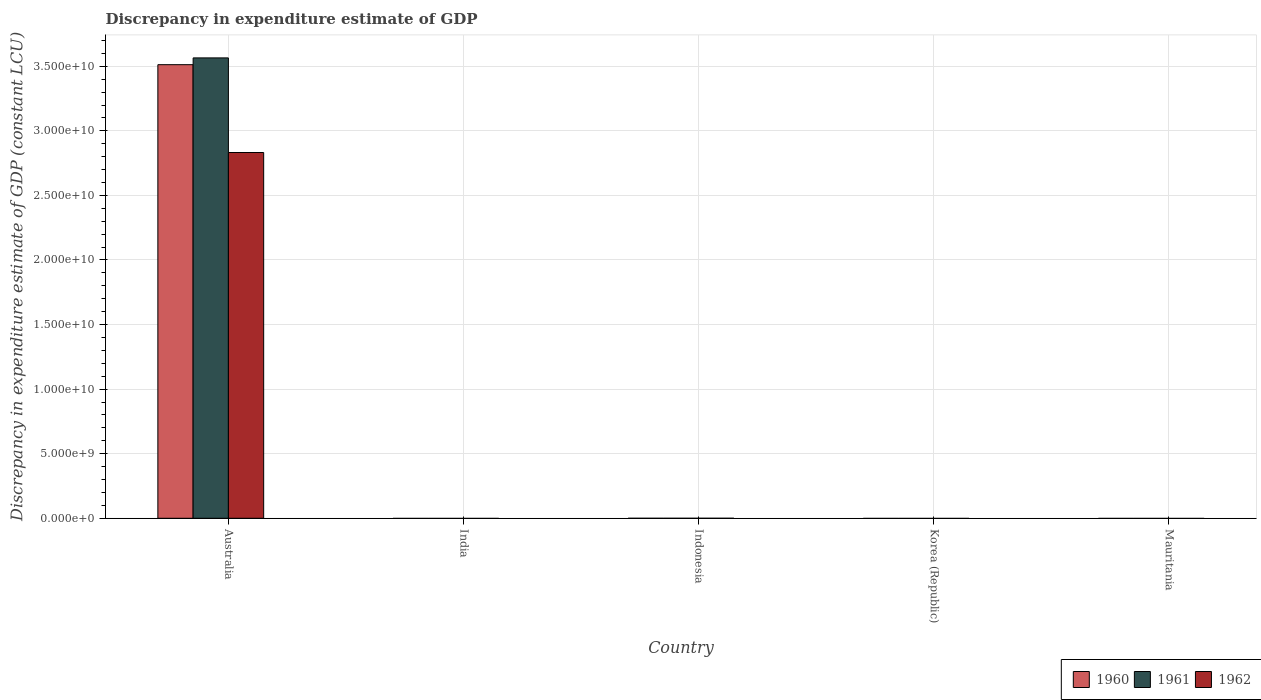How many different coloured bars are there?
Provide a succinct answer. 3. Are the number of bars per tick equal to the number of legend labels?
Provide a succinct answer. No. What is the label of the 3rd group of bars from the left?
Your response must be concise. Indonesia. What is the discrepancy in expenditure estimate of GDP in 1961 in Australia?
Offer a terse response. 3.56e+1. Across all countries, what is the maximum discrepancy in expenditure estimate of GDP in 1960?
Make the answer very short. 3.51e+1. Across all countries, what is the minimum discrepancy in expenditure estimate of GDP in 1961?
Offer a very short reply. 0. In which country was the discrepancy in expenditure estimate of GDP in 1961 maximum?
Provide a short and direct response. Australia. What is the total discrepancy in expenditure estimate of GDP in 1962 in the graph?
Offer a terse response. 2.83e+1. What is the difference between the discrepancy in expenditure estimate of GDP in 1962 in Mauritania and the discrepancy in expenditure estimate of GDP in 1961 in India?
Offer a terse response. 0. What is the average discrepancy in expenditure estimate of GDP in 1960 per country?
Your answer should be very brief. 7.02e+09. What is the difference between the discrepancy in expenditure estimate of GDP of/in 1960 and discrepancy in expenditure estimate of GDP of/in 1961 in Australia?
Provide a short and direct response. -5.25e+08. What is the difference between the highest and the lowest discrepancy in expenditure estimate of GDP in 1962?
Offer a very short reply. 2.83e+1. In how many countries, is the discrepancy in expenditure estimate of GDP in 1960 greater than the average discrepancy in expenditure estimate of GDP in 1960 taken over all countries?
Make the answer very short. 1. Is it the case that in every country, the sum of the discrepancy in expenditure estimate of GDP in 1961 and discrepancy in expenditure estimate of GDP in 1962 is greater than the discrepancy in expenditure estimate of GDP in 1960?
Keep it short and to the point. No. What is the difference between two consecutive major ticks on the Y-axis?
Offer a terse response. 5.00e+09. Are the values on the major ticks of Y-axis written in scientific E-notation?
Your answer should be very brief. Yes. Does the graph contain any zero values?
Make the answer very short. Yes. What is the title of the graph?
Make the answer very short. Discrepancy in expenditure estimate of GDP. What is the label or title of the Y-axis?
Your answer should be compact. Discrepancy in expenditure estimate of GDP (constant LCU). What is the Discrepancy in expenditure estimate of GDP (constant LCU) of 1960 in Australia?
Your response must be concise. 3.51e+1. What is the Discrepancy in expenditure estimate of GDP (constant LCU) in 1961 in Australia?
Provide a succinct answer. 3.56e+1. What is the Discrepancy in expenditure estimate of GDP (constant LCU) of 1962 in Australia?
Offer a terse response. 2.83e+1. What is the Discrepancy in expenditure estimate of GDP (constant LCU) of 1962 in India?
Provide a succinct answer. 0. What is the Discrepancy in expenditure estimate of GDP (constant LCU) of 1962 in Indonesia?
Offer a very short reply. 0. What is the Discrepancy in expenditure estimate of GDP (constant LCU) of 1960 in Korea (Republic)?
Provide a succinct answer. 0. What is the Discrepancy in expenditure estimate of GDP (constant LCU) in 1962 in Korea (Republic)?
Your response must be concise. 0. What is the Discrepancy in expenditure estimate of GDP (constant LCU) of 1961 in Mauritania?
Offer a very short reply. 0. Across all countries, what is the maximum Discrepancy in expenditure estimate of GDP (constant LCU) of 1960?
Your response must be concise. 3.51e+1. Across all countries, what is the maximum Discrepancy in expenditure estimate of GDP (constant LCU) in 1961?
Offer a terse response. 3.56e+1. Across all countries, what is the maximum Discrepancy in expenditure estimate of GDP (constant LCU) in 1962?
Give a very brief answer. 2.83e+1. Across all countries, what is the minimum Discrepancy in expenditure estimate of GDP (constant LCU) in 1960?
Offer a very short reply. 0. Across all countries, what is the minimum Discrepancy in expenditure estimate of GDP (constant LCU) of 1961?
Provide a succinct answer. 0. Across all countries, what is the minimum Discrepancy in expenditure estimate of GDP (constant LCU) of 1962?
Offer a very short reply. 0. What is the total Discrepancy in expenditure estimate of GDP (constant LCU) of 1960 in the graph?
Offer a very short reply. 3.51e+1. What is the total Discrepancy in expenditure estimate of GDP (constant LCU) in 1961 in the graph?
Provide a succinct answer. 3.56e+1. What is the total Discrepancy in expenditure estimate of GDP (constant LCU) of 1962 in the graph?
Give a very brief answer. 2.83e+1. What is the average Discrepancy in expenditure estimate of GDP (constant LCU) of 1960 per country?
Your response must be concise. 7.02e+09. What is the average Discrepancy in expenditure estimate of GDP (constant LCU) in 1961 per country?
Your response must be concise. 7.13e+09. What is the average Discrepancy in expenditure estimate of GDP (constant LCU) of 1962 per country?
Offer a very short reply. 5.66e+09. What is the difference between the Discrepancy in expenditure estimate of GDP (constant LCU) in 1960 and Discrepancy in expenditure estimate of GDP (constant LCU) in 1961 in Australia?
Give a very brief answer. -5.25e+08. What is the difference between the Discrepancy in expenditure estimate of GDP (constant LCU) in 1960 and Discrepancy in expenditure estimate of GDP (constant LCU) in 1962 in Australia?
Offer a very short reply. 6.80e+09. What is the difference between the Discrepancy in expenditure estimate of GDP (constant LCU) in 1961 and Discrepancy in expenditure estimate of GDP (constant LCU) in 1962 in Australia?
Provide a succinct answer. 7.33e+09. What is the difference between the highest and the lowest Discrepancy in expenditure estimate of GDP (constant LCU) in 1960?
Ensure brevity in your answer.  3.51e+1. What is the difference between the highest and the lowest Discrepancy in expenditure estimate of GDP (constant LCU) in 1961?
Provide a succinct answer. 3.56e+1. What is the difference between the highest and the lowest Discrepancy in expenditure estimate of GDP (constant LCU) in 1962?
Provide a short and direct response. 2.83e+1. 